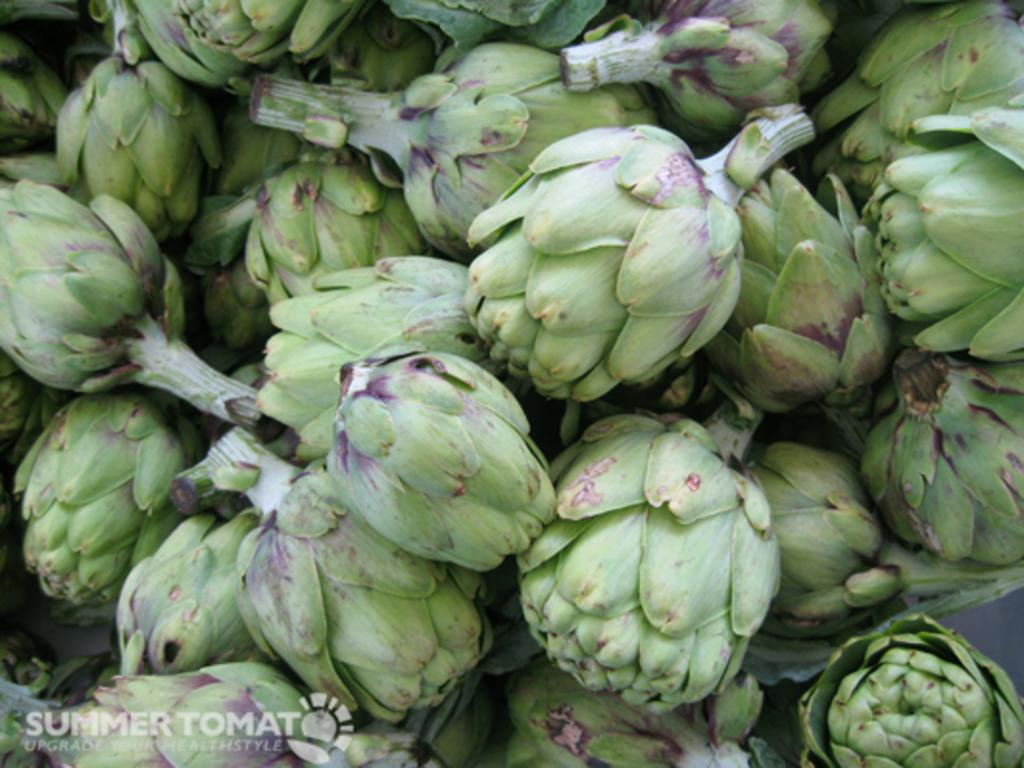What type of plants are in the image? There is a group of artichokes in the image. What type of cow can be seen grazing in the artichoke patch in the image? There is no cow or artichoke patch present in the image; it only features a group of artichokes. 